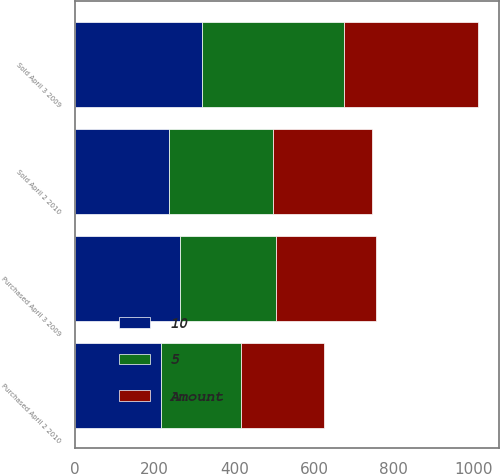<chart> <loc_0><loc_0><loc_500><loc_500><stacked_bar_chart><ecel><fcel>Purchased April 2 2010<fcel>Sold April 2 2010<fcel>Purchased April 3 2009<fcel>Sold April 3 2009<nl><fcel>10<fcel>217<fcel>236<fcel>264<fcel>320<nl><fcel>Amount<fcel>209<fcel>248<fcel>252<fcel>337<nl><fcel>5<fcel>199<fcel>260<fcel>240<fcel>355<nl></chart> 